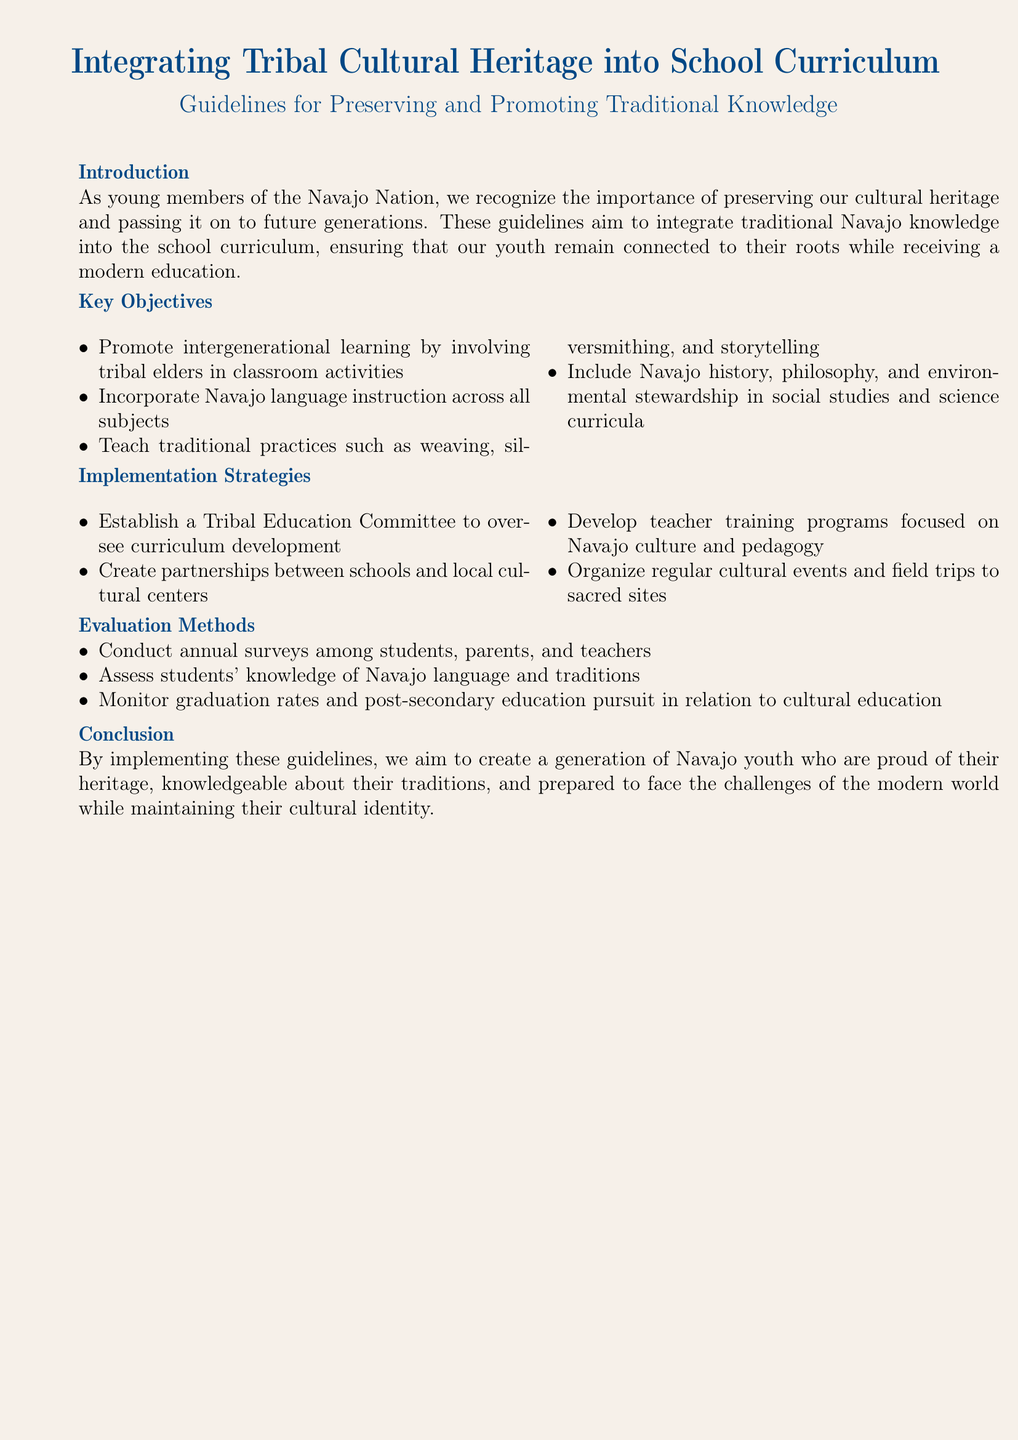What is the document's main title? The title indicates the primary focus of the document, which is "Integrating Tribal Cultural Heritage into School Curriculum."
Answer: Integrating Tribal Cultural Heritage into School Curriculum Who is involved in intergenerational learning activities? The document specifies that tribal elders are to be involved in classroom activities for intergenerational learning.
Answer: Tribal elders What traditional practices are included in the curriculum? The guidelines mention weaving, silversmithing, and storytelling as traditional practices to be taught.
Answer: Weaving, silversmithing, and storytelling What committee is proposed for curriculum development? The document mentions establishing a Tribal Education Committee to oversee this development.
Answer: Tribal Education Committee What is one of the evaluation methods stated? The document states that annual surveys among students, parents, and teachers will be conducted as an evaluation method.
Answer: Annual surveys What is the goal of implementing these guidelines? The primary goal articulated in the document is to create a generation of Navajo youth who are proud of their heritage.
Answer: Proud of their heritage How often will surveys be conducted? The document specifies that surveys will be conducted annually.
Answer: Annually What type of education program is proposed for teachers? The guidelines suggest developing teacher training programs focused on Navajo culture and pedagogy.
Answer: Teacher training programs Where should cultural events and field trips occur? The document recommends organizing these events at sacred sites.
Answer: Sacred sites 